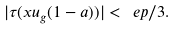<formula> <loc_0><loc_0><loc_500><loc_500>| \tau ( x u _ { g } ( 1 - a ) ) | < \ e p / 3 .</formula> 